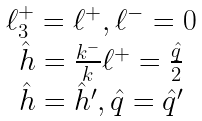<formula> <loc_0><loc_0><loc_500><loc_500>\begin{array} { c } \ell _ { 3 } ^ { + } = \ell ^ { + } , \ell ^ { - } = 0 \\ \hat { h } = \frac { k ^ { - } } { k } \ell ^ { + } = \frac { \hat { q } } { 2 } \\ \hat { h } = \hat { h } ^ { \prime } , \hat { q } = \hat { q } ^ { \prime } \end{array}</formula> 